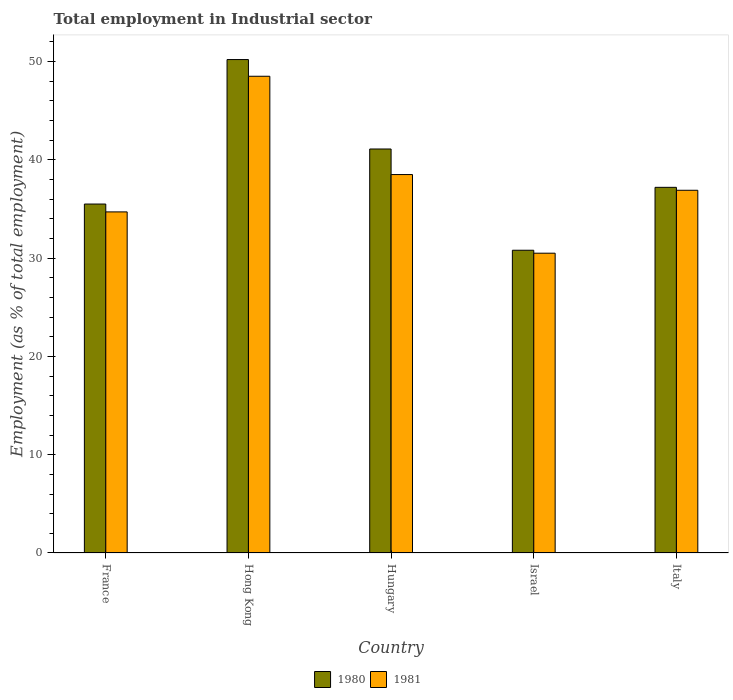How many different coloured bars are there?
Your response must be concise. 2. Are the number of bars on each tick of the X-axis equal?
Your answer should be compact. Yes. How many bars are there on the 3rd tick from the left?
Offer a terse response. 2. What is the label of the 3rd group of bars from the left?
Offer a terse response. Hungary. What is the employment in industrial sector in 1981 in Israel?
Offer a very short reply. 30.5. Across all countries, what is the maximum employment in industrial sector in 1981?
Offer a terse response. 48.5. Across all countries, what is the minimum employment in industrial sector in 1981?
Give a very brief answer. 30.5. In which country was the employment in industrial sector in 1981 maximum?
Keep it short and to the point. Hong Kong. In which country was the employment in industrial sector in 1981 minimum?
Your answer should be compact. Israel. What is the total employment in industrial sector in 1980 in the graph?
Your answer should be very brief. 194.8. What is the difference between the employment in industrial sector in 1980 in Hungary and that in Italy?
Ensure brevity in your answer.  3.9. What is the difference between the employment in industrial sector in 1981 in France and the employment in industrial sector in 1980 in Israel?
Provide a succinct answer. 3.9. What is the average employment in industrial sector in 1980 per country?
Keep it short and to the point. 38.96. What is the difference between the employment in industrial sector of/in 1980 and employment in industrial sector of/in 1981 in Hungary?
Provide a short and direct response. 2.6. In how many countries, is the employment in industrial sector in 1981 greater than 42 %?
Give a very brief answer. 1. What is the ratio of the employment in industrial sector in 1980 in Hong Kong to that in Hungary?
Ensure brevity in your answer.  1.22. Is the employment in industrial sector in 1981 in Hong Kong less than that in Italy?
Your answer should be compact. No. Is the difference between the employment in industrial sector in 1980 in France and Hungary greater than the difference between the employment in industrial sector in 1981 in France and Hungary?
Make the answer very short. No. What is the difference between the highest and the second highest employment in industrial sector in 1981?
Your answer should be very brief. 11.6. What is the difference between the highest and the lowest employment in industrial sector in 1980?
Give a very brief answer. 19.4. In how many countries, is the employment in industrial sector in 1981 greater than the average employment in industrial sector in 1981 taken over all countries?
Offer a terse response. 2. What does the 1st bar from the left in Italy represents?
Your answer should be very brief. 1980. How many bars are there?
Make the answer very short. 10. Are all the bars in the graph horizontal?
Provide a succinct answer. No. How many countries are there in the graph?
Make the answer very short. 5. Does the graph contain any zero values?
Your answer should be very brief. No. Does the graph contain grids?
Offer a terse response. No. How are the legend labels stacked?
Your response must be concise. Horizontal. What is the title of the graph?
Your response must be concise. Total employment in Industrial sector. What is the label or title of the X-axis?
Offer a terse response. Country. What is the label or title of the Y-axis?
Your answer should be very brief. Employment (as % of total employment). What is the Employment (as % of total employment) in 1980 in France?
Offer a very short reply. 35.5. What is the Employment (as % of total employment) in 1981 in France?
Your response must be concise. 34.7. What is the Employment (as % of total employment) in 1980 in Hong Kong?
Ensure brevity in your answer.  50.2. What is the Employment (as % of total employment) in 1981 in Hong Kong?
Provide a succinct answer. 48.5. What is the Employment (as % of total employment) of 1980 in Hungary?
Your answer should be very brief. 41.1. What is the Employment (as % of total employment) of 1981 in Hungary?
Offer a terse response. 38.5. What is the Employment (as % of total employment) of 1980 in Israel?
Offer a very short reply. 30.8. What is the Employment (as % of total employment) of 1981 in Israel?
Your answer should be compact. 30.5. What is the Employment (as % of total employment) in 1980 in Italy?
Your response must be concise. 37.2. What is the Employment (as % of total employment) in 1981 in Italy?
Your answer should be very brief. 36.9. Across all countries, what is the maximum Employment (as % of total employment) of 1980?
Offer a very short reply. 50.2. Across all countries, what is the maximum Employment (as % of total employment) in 1981?
Your answer should be very brief. 48.5. Across all countries, what is the minimum Employment (as % of total employment) in 1980?
Ensure brevity in your answer.  30.8. Across all countries, what is the minimum Employment (as % of total employment) of 1981?
Your response must be concise. 30.5. What is the total Employment (as % of total employment) of 1980 in the graph?
Provide a succinct answer. 194.8. What is the total Employment (as % of total employment) of 1981 in the graph?
Your response must be concise. 189.1. What is the difference between the Employment (as % of total employment) of 1980 in France and that in Hong Kong?
Provide a short and direct response. -14.7. What is the difference between the Employment (as % of total employment) in 1980 in France and that in Italy?
Provide a succinct answer. -1.7. What is the difference between the Employment (as % of total employment) of 1980 in Hong Kong and that in Israel?
Offer a very short reply. 19.4. What is the difference between the Employment (as % of total employment) in 1981 in Hong Kong and that in Israel?
Keep it short and to the point. 18. What is the difference between the Employment (as % of total employment) in 1981 in Hong Kong and that in Italy?
Your response must be concise. 11.6. What is the difference between the Employment (as % of total employment) of 1981 in Hungary and that in Italy?
Make the answer very short. 1.6. What is the difference between the Employment (as % of total employment) in 1980 in Israel and that in Italy?
Offer a terse response. -6.4. What is the difference between the Employment (as % of total employment) of 1980 in France and the Employment (as % of total employment) of 1981 in Hong Kong?
Give a very brief answer. -13. What is the difference between the Employment (as % of total employment) of 1980 in France and the Employment (as % of total employment) of 1981 in Israel?
Provide a succinct answer. 5. What is the difference between the Employment (as % of total employment) of 1980 in Hong Kong and the Employment (as % of total employment) of 1981 in Israel?
Your answer should be compact. 19.7. What is the difference between the Employment (as % of total employment) in 1980 in Hungary and the Employment (as % of total employment) in 1981 in Israel?
Your answer should be compact. 10.6. What is the difference between the Employment (as % of total employment) in 1980 in Israel and the Employment (as % of total employment) in 1981 in Italy?
Give a very brief answer. -6.1. What is the average Employment (as % of total employment) in 1980 per country?
Ensure brevity in your answer.  38.96. What is the average Employment (as % of total employment) of 1981 per country?
Your response must be concise. 37.82. What is the difference between the Employment (as % of total employment) of 1980 and Employment (as % of total employment) of 1981 in Italy?
Provide a short and direct response. 0.3. What is the ratio of the Employment (as % of total employment) of 1980 in France to that in Hong Kong?
Provide a short and direct response. 0.71. What is the ratio of the Employment (as % of total employment) of 1981 in France to that in Hong Kong?
Keep it short and to the point. 0.72. What is the ratio of the Employment (as % of total employment) of 1980 in France to that in Hungary?
Offer a terse response. 0.86. What is the ratio of the Employment (as % of total employment) of 1981 in France to that in Hungary?
Make the answer very short. 0.9. What is the ratio of the Employment (as % of total employment) of 1980 in France to that in Israel?
Keep it short and to the point. 1.15. What is the ratio of the Employment (as % of total employment) in 1981 in France to that in Israel?
Ensure brevity in your answer.  1.14. What is the ratio of the Employment (as % of total employment) of 1980 in France to that in Italy?
Provide a succinct answer. 0.95. What is the ratio of the Employment (as % of total employment) of 1981 in France to that in Italy?
Your answer should be very brief. 0.94. What is the ratio of the Employment (as % of total employment) in 1980 in Hong Kong to that in Hungary?
Your answer should be compact. 1.22. What is the ratio of the Employment (as % of total employment) in 1981 in Hong Kong to that in Hungary?
Give a very brief answer. 1.26. What is the ratio of the Employment (as % of total employment) in 1980 in Hong Kong to that in Israel?
Give a very brief answer. 1.63. What is the ratio of the Employment (as % of total employment) in 1981 in Hong Kong to that in Israel?
Provide a short and direct response. 1.59. What is the ratio of the Employment (as % of total employment) in 1980 in Hong Kong to that in Italy?
Your response must be concise. 1.35. What is the ratio of the Employment (as % of total employment) in 1981 in Hong Kong to that in Italy?
Your answer should be very brief. 1.31. What is the ratio of the Employment (as % of total employment) of 1980 in Hungary to that in Israel?
Your response must be concise. 1.33. What is the ratio of the Employment (as % of total employment) of 1981 in Hungary to that in Israel?
Your answer should be compact. 1.26. What is the ratio of the Employment (as % of total employment) of 1980 in Hungary to that in Italy?
Provide a short and direct response. 1.1. What is the ratio of the Employment (as % of total employment) in 1981 in Hungary to that in Italy?
Your answer should be compact. 1.04. What is the ratio of the Employment (as % of total employment) of 1980 in Israel to that in Italy?
Give a very brief answer. 0.83. What is the ratio of the Employment (as % of total employment) in 1981 in Israel to that in Italy?
Provide a short and direct response. 0.83. What is the difference between the highest and the second highest Employment (as % of total employment) of 1980?
Keep it short and to the point. 9.1. What is the difference between the highest and the second highest Employment (as % of total employment) in 1981?
Ensure brevity in your answer.  10. 